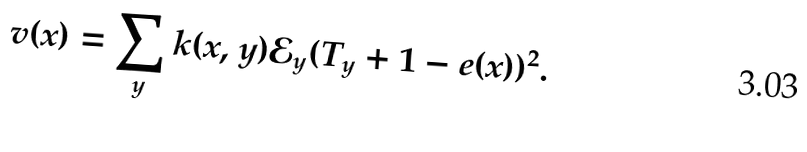<formula> <loc_0><loc_0><loc_500><loc_500>v ( x ) = \sum _ { y } k ( x , y ) \mathcal { E } _ { y } ( T _ { y } + 1 - e ( x ) ) ^ { 2 } .</formula> 